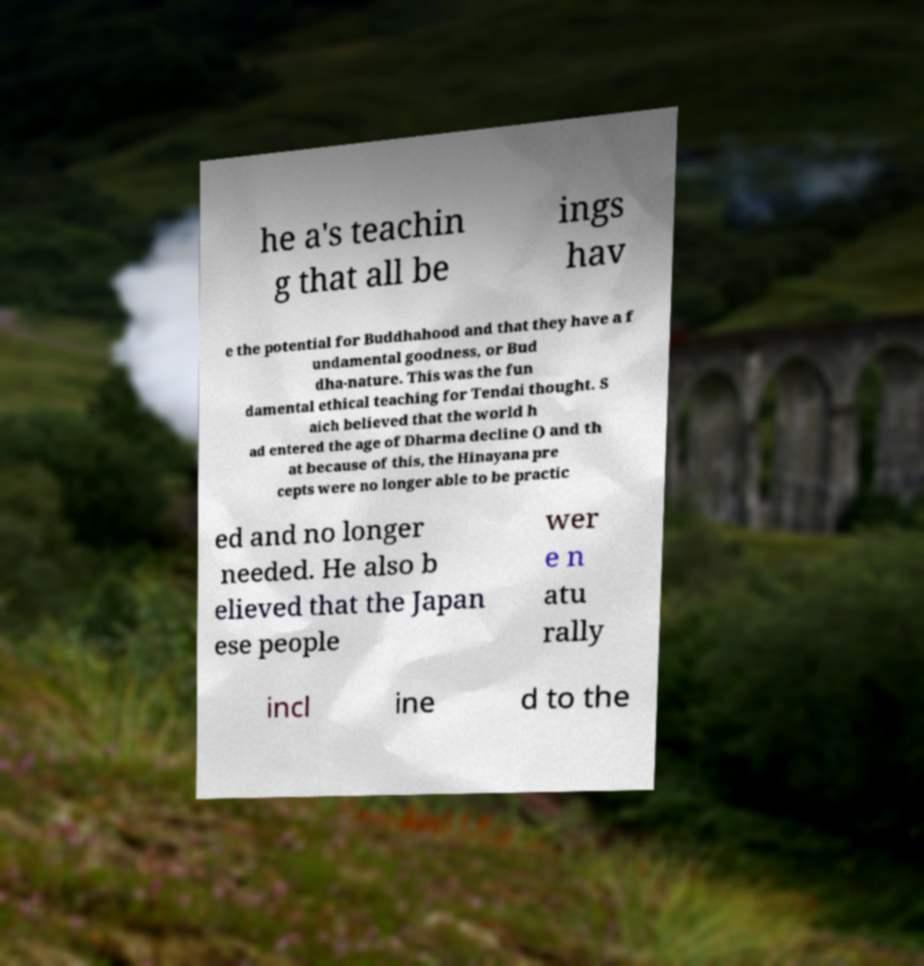Can you read and provide the text displayed in the image?This photo seems to have some interesting text. Can you extract and type it out for me? he a's teachin g that all be ings hav e the potential for Buddhahood and that they have a f undamental goodness, or Bud dha-nature. This was the fun damental ethical teaching for Tendai thought. S aich believed that the world h ad entered the age of Dharma decline () and th at because of this, the Hinayana pre cepts were no longer able to be practic ed and no longer needed. He also b elieved that the Japan ese people wer e n atu rally incl ine d to the 